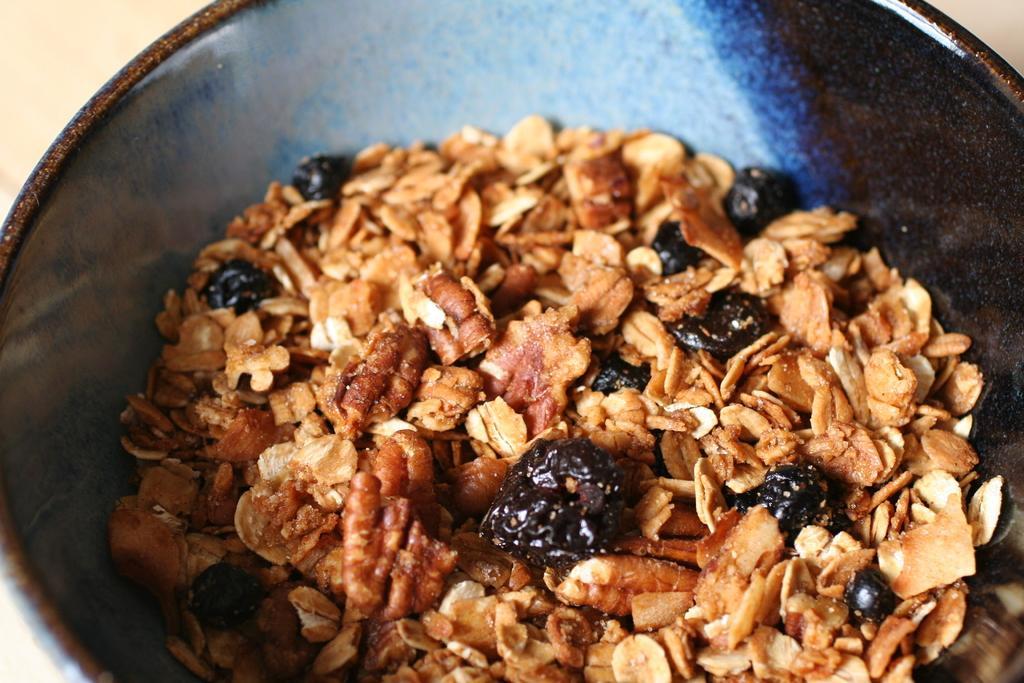How would you summarize this image in a sentence or two? In this image we can see the food item in the black color vessel which is on the surface. 